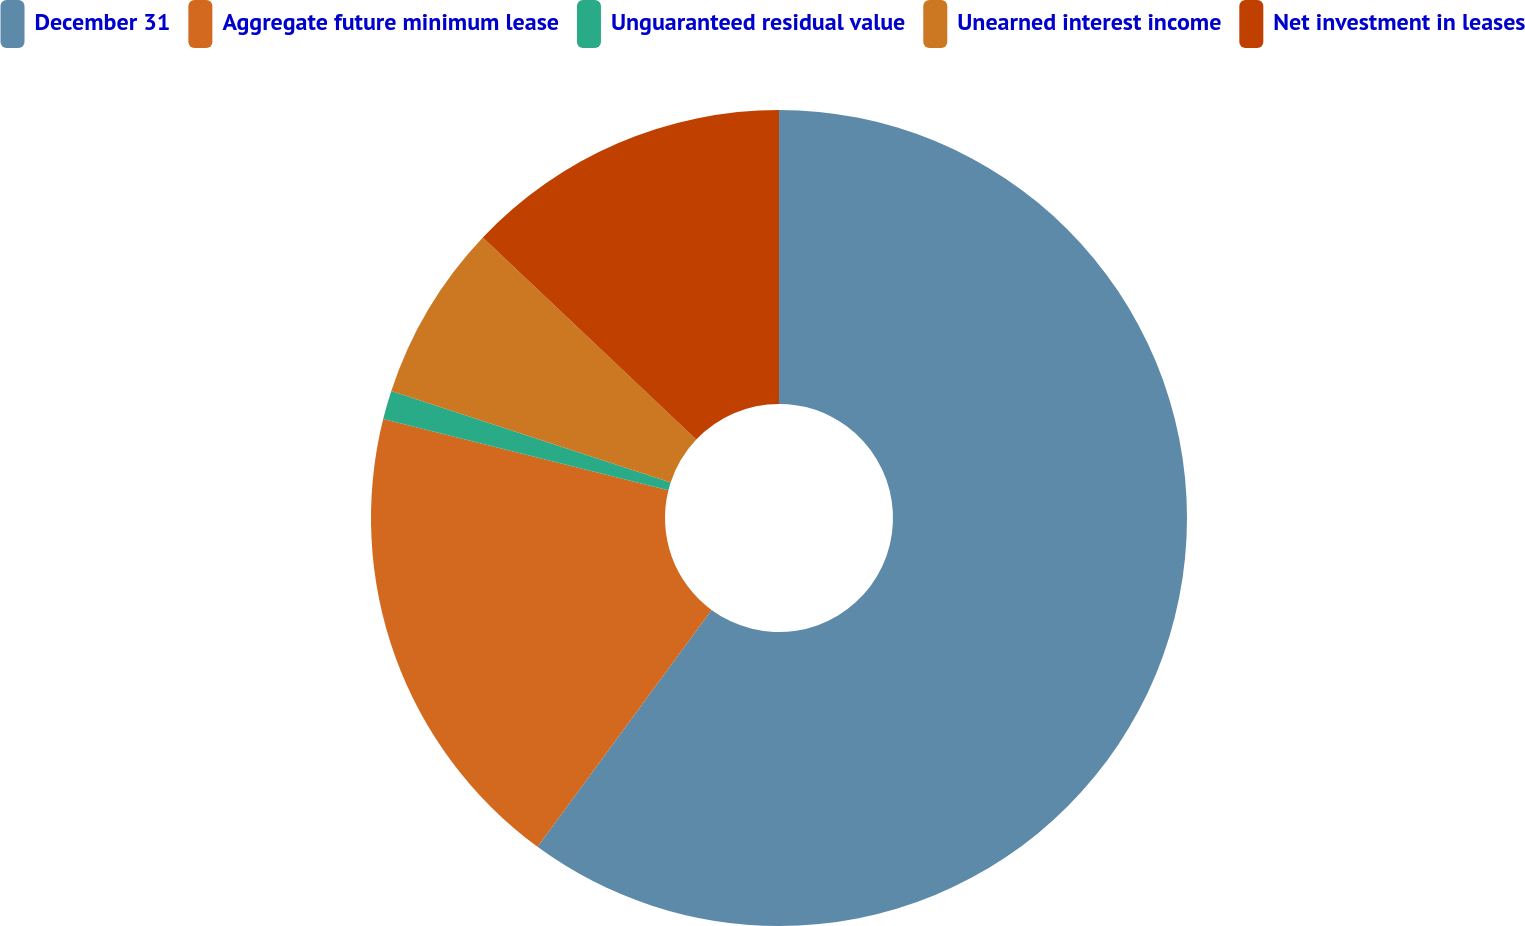Convert chart to OTSL. <chart><loc_0><loc_0><loc_500><loc_500><pie_chart><fcel>December 31<fcel>Aggregate future minimum lease<fcel>Unguaranteed residual value<fcel>Unearned interest income<fcel>Net investment in leases<nl><fcel>60.08%<fcel>18.82%<fcel>1.14%<fcel>7.03%<fcel>12.93%<nl></chart> 